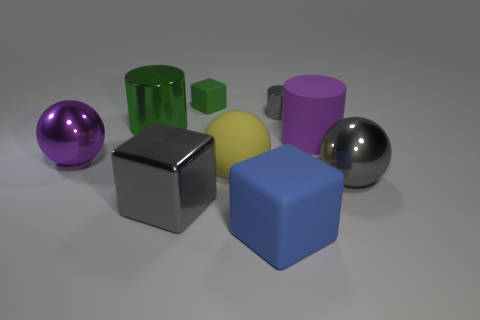Add 1 large gray spheres. How many objects exist? 10 Subtract all cylinders. How many objects are left? 6 Subtract all tiny green objects. Subtract all big green metallic things. How many objects are left? 7 Add 2 tiny green rubber cubes. How many tiny green rubber cubes are left? 3 Add 1 gray shiny cubes. How many gray shiny cubes exist? 2 Subtract 0 brown cylinders. How many objects are left? 9 